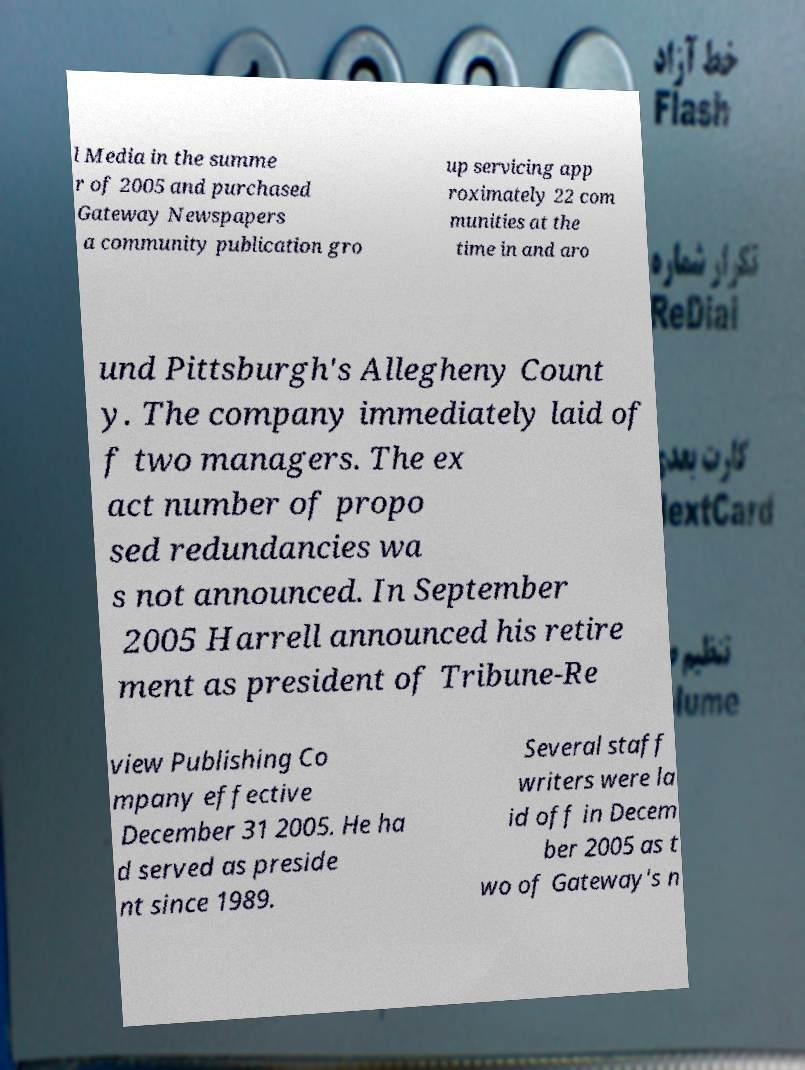I need the written content from this picture converted into text. Can you do that? l Media in the summe r of 2005 and purchased Gateway Newspapers a community publication gro up servicing app roximately 22 com munities at the time in and aro und Pittsburgh's Allegheny Count y. The company immediately laid of f two managers. The ex act number of propo sed redundancies wa s not announced. In September 2005 Harrell announced his retire ment as president of Tribune-Re view Publishing Co mpany effective December 31 2005. He ha d served as preside nt since 1989. Several staff writers were la id off in Decem ber 2005 as t wo of Gateway's n 